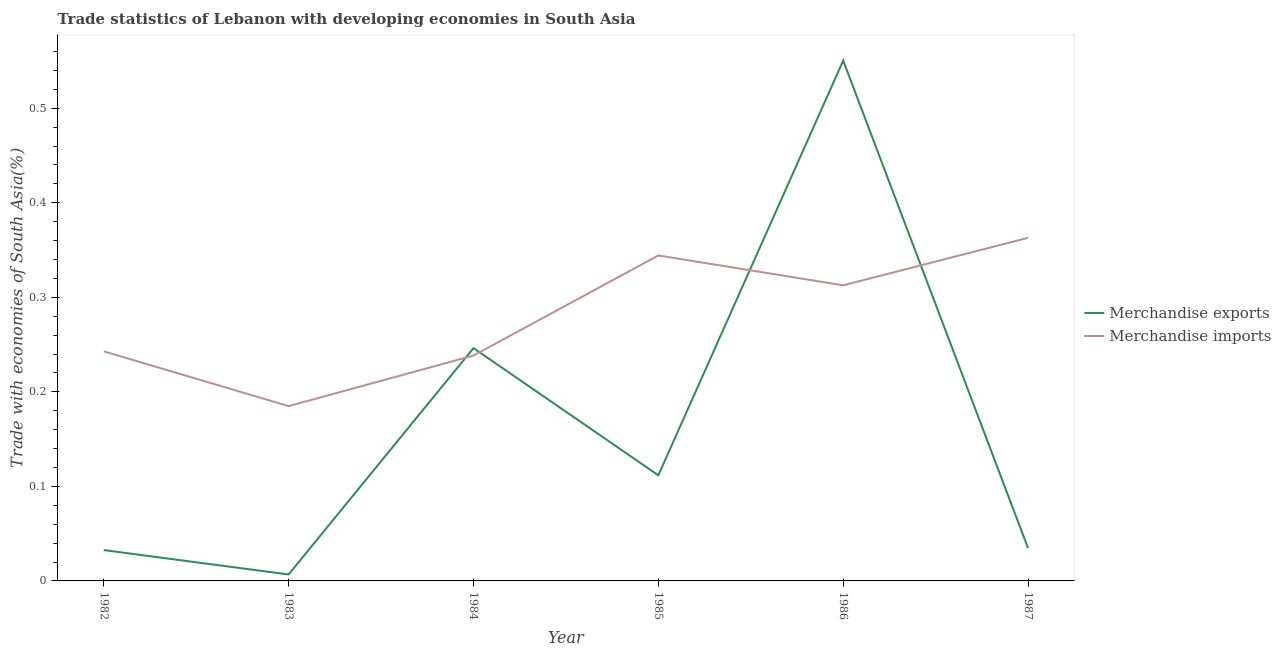Does the line corresponding to merchandise imports intersect with the line corresponding to merchandise exports?
Provide a succinct answer. Yes. What is the merchandise imports in 1987?
Offer a terse response. 0.36. Across all years, what is the maximum merchandise exports?
Your answer should be very brief. 0.55. Across all years, what is the minimum merchandise exports?
Your response must be concise. 0.01. In which year was the merchandise imports maximum?
Your answer should be very brief. 1987. In which year was the merchandise exports minimum?
Offer a terse response. 1983. What is the total merchandise imports in the graph?
Your answer should be compact. 1.69. What is the difference between the merchandise exports in 1983 and that in 1984?
Your answer should be very brief. -0.24. What is the difference between the merchandise imports in 1985 and the merchandise exports in 1983?
Make the answer very short. 0.34. What is the average merchandise imports per year?
Offer a very short reply. 0.28. In the year 1987, what is the difference between the merchandise exports and merchandise imports?
Make the answer very short. -0.33. What is the ratio of the merchandise imports in 1983 to that in 1987?
Keep it short and to the point. 0.51. Is the merchandise exports in 1983 less than that in 1984?
Offer a terse response. Yes. What is the difference between the highest and the second highest merchandise exports?
Make the answer very short. 0.3. What is the difference between the highest and the lowest merchandise exports?
Your response must be concise. 0.54. In how many years, is the merchandise imports greater than the average merchandise imports taken over all years?
Your answer should be compact. 3. Is the merchandise imports strictly greater than the merchandise exports over the years?
Offer a terse response. No. What is the difference between two consecutive major ticks on the Y-axis?
Keep it short and to the point. 0.1. Does the graph contain any zero values?
Provide a succinct answer. No. Does the graph contain grids?
Give a very brief answer. No. How many legend labels are there?
Provide a succinct answer. 2. How are the legend labels stacked?
Your answer should be very brief. Vertical. What is the title of the graph?
Offer a very short reply. Trade statistics of Lebanon with developing economies in South Asia. Does "Registered firms" appear as one of the legend labels in the graph?
Offer a very short reply. No. What is the label or title of the X-axis?
Your response must be concise. Year. What is the label or title of the Y-axis?
Give a very brief answer. Trade with economies of South Asia(%). What is the Trade with economies of South Asia(%) of Merchandise exports in 1982?
Give a very brief answer. 0.03. What is the Trade with economies of South Asia(%) of Merchandise imports in 1982?
Offer a very short reply. 0.24. What is the Trade with economies of South Asia(%) in Merchandise exports in 1983?
Offer a very short reply. 0.01. What is the Trade with economies of South Asia(%) in Merchandise imports in 1983?
Your answer should be very brief. 0.18. What is the Trade with economies of South Asia(%) in Merchandise exports in 1984?
Your answer should be compact. 0.25. What is the Trade with economies of South Asia(%) of Merchandise imports in 1984?
Ensure brevity in your answer.  0.24. What is the Trade with economies of South Asia(%) in Merchandise exports in 1985?
Offer a very short reply. 0.11. What is the Trade with economies of South Asia(%) of Merchandise imports in 1985?
Ensure brevity in your answer.  0.34. What is the Trade with economies of South Asia(%) of Merchandise exports in 1986?
Make the answer very short. 0.55. What is the Trade with economies of South Asia(%) in Merchandise imports in 1986?
Offer a terse response. 0.31. What is the Trade with economies of South Asia(%) of Merchandise exports in 1987?
Keep it short and to the point. 0.03. What is the Trade with economies of South Asia(%) of Merchandise imports in 1987?
Ensure brevity in your answer.  0.36. Across all years, what is the maximum Trade with economies of South Asia(%) in Merchandise exports?
Your response must be concise. 0.55. Across all years, what is the maximum Trade with economies of South Asia(%) of Merchandise imports?
Make the answer very short. 0.36. Across all years, what is the minimum Trade with economies of South Asia(%) in Merchandise exports?
Ensure brevity in your answer.  0.01. Across all years, what is the minimum Trade with economies of South Asia(%) in Merchandise imports?
Offer a very short reply. 0.18. What is the total Trade with economies of South Asia(%) of Merchandise exports in the graph?
Provide a succinct answer. 0.98. What is the total Trade with economies of South Asia(%) in Merchandise imports in the graph?
Provide a succinct answer. 1.69. What is the difference between the Trade with economies of South Asia(%) of Merchandise exports in 1982 and that in 1983?
Make the answer very short. 0.03. What is the difference between the Trade with economies of South Asia(%) of Merchandise imports in 1982 and that in 1983?
Keep it short and to the point. 0.06. What is the difference between the Trade with economies of South Asia(%) in Merchandise exports in 1982 and that in 1984?
Offer a very short reply. -0.21. What is the difference between the Trade with economies of South Asia(%) in Merchandise imports in 1982 and that in 1984?
Keep it short and to the point. 0. What is the difference between the Trade with economies of South Asia(%) in Merchandise exports in 1982 and that in 1985?
Your answer should be compact. -0.08. What is the difference between the Trade with economies of South Asia(%) in Merchandise imports in 1982 and that in 1985?
Provide a succinct answer. -0.1. What is the difference between the Trade with economies of South Asia(%) of Merchandise exports in 1982 and that in 1986?
Give a very brief answer. -0.52. What is the difference between the Trade with economies of South Asia(%) of Merchandise imports in 1982 and that in 1986?
Keep it short and to the point. -0.07. What is the difference between the Trade with economies of South Asia(%) in Merchandise exports in 1982 and that in 1987?
Provide a succinct answer. -0. What is the difference between the Trade with economies of South Asia(%) of Merchandise imports in 1982 and that in 1987?
Give a very brief answer. -0.12. What is the difference between the Trade with economies of South Asia(%) in Merchandise exports in 1983 and that in 1984?
Provide a succinct answer. -0.24. What is the difference between the Trade with economies of South Asia(%) in Merchandise imports in 1983 and that in 1984?
Make the answer very short. -0.05. What is the difference between the Trade with economies of South Asia(%) of Merchandise exports in 1983 and that in 1985?
Offer a very short reply. -0.1. What is the difference between the Trade with economies of South Asia(%) of Merchandise imports in 1983 and that in 1985?
Your answer should be very brief. -0.16. What is the difference between the Trade with economies of South Asia(%) of Merchandise exports in 1983 and that in 1986?
Give a very brief answer. -0.54. What is the difference between the Trade with economies of South Asia(%) of Merchandise imports in 1983 and that in 1986?
Offer a terse response. -0.13. What is the difference between the Trade with economies of South Asia(%) of Merchandise exports in 1983 and that in 1987?
Your response must be concise. -0.03. What is the difference between the Trade with economies of South Asia(%) in Merchandise imports in 1983 and that in 1987?
Keep it short and to the point. -0.18. What is the difference between the Trade with economies of South Asia(%) in Merchandise exports in 1984 and that in 1985?
Keep it short and to the point. 0.13. What is the difference between the Trade with economies of South Asia(%) of Merchandise imports in 1984 and that in 1985?
Offer a very short reply. -0.11. What is the difference between the Trade with economies of South Asia(%) of Merchandise exports in 1984 and that in 1986?
Give a very brief answer. -0.3. What is the difference between the Trade with economies of South Asia(%) in Merchandise imports in 1984 and that in 1986?
Offer a very short reply. -0.07. What is the difference between the Trade with economies of South Asia(%) of Merchandise exports in 1984 and that in 1987?
Your answer should be compact. 0.21. What is the difference between the Trade with economies of South Asia(%) of Merchandise imports in 1984 and that in 1987?
Offer a terse response. -0.12. What is the difference between the Trade with economies of South Asia(%) of Merchandise exports in 1985 and that in 1986?
Offer a very short reply. -0.44. What is the difference between the Trade with economies of South Asia(%) of Merchandise imports in 1985 and that in 1986?
Provide a succinct answer. 0.03. What is the difference between the Trade with economies of South Asia(%) of Merchandise exports in 1985 and that in 1987?
Your answer should be compact. 0.08. What is the difference between the Trade with economies of South Asia(%) of Merchandise imports in 1985 and that in 1987?
Make the answer very short. -0.02. What is the difference between the Trade with economies of South Asia(%) in Merchandise exports in 1986 and that in 1987?
Provide a succinct answer. 0.52. What is the difference between the Trade with economies of South Asia(%) in Merchandise imports in 1986 and that in 1987?
Provide a succinct answer. -0.05. What is the difference between the Trade with economies of South Asia(%) in Merchandise exports in 1982 and the Trade with economies of South Asia(%) in Merchandise imports in 1983?
Provide a short and direct response. -0.15. What is the difference between the Trade with economies of South Asia(%) of Merchandise exports in 1982 and the Trade with economies of South Asia(%) of Merchandise imports in 1984?
Your answer should be compact. -0.21. What is the difference between the Trade with economies of South Asia(%) in Merchandise exports in 1982 and the Trade with economies of South Asia(%) in Merchandise imports in 1985?
Your answer should be compact. -0.31. What is the difference between the Trade with economies of South Asia(%) in Merchandise exports in 1982 and the Trade with economies of South Asia(%) in Merchandise imports in 1986?
Offer a terse response. -0.28. What is the difference between the Trade with economies of South Asia(%) in Merchandise exports in 1982 and the Trade with economies of South Asia(%) in Merchandise imports in 1987?
Your answer should be compact. -0.33. What is the difference between the Trade with economies of South Asia(%) in Merchandise exports in 1983 and the Trade with economies of South Asia(%) in Merchandise imports in 1984?
Offer a very short reply. -0.23. What is the difference between the Trade with economies of South Asia(%) of Merchandise exports in 1983 and the Trade with economies of South Asia(%) of Merchandise imports in 1985?
Keep it short and to the point. -0.34. What is the difference between the Trade with economies of South Asia(%) in Merchandise exports in 1983 and the Trade with economies of South Asia(%) in Merchandise imports in 1986?
Give a very brief answer. -0.31. What is the difference between the Trade with economies of South Asia(%) in Merchandise exports in 1983 and the Trade with economies of South Asia(%) in Merchandise imports in 1987?
Make the answer very short. -0.36. What is the difference between the Trade with economies of South Asia(%) in Merchandise exports in 1984 and the Trade with economies of South Asia(%) in Merchandise imports in 1985?
Make the answer very short. -0.1. What is the difference between the Trade with economies of South Asia(%) of Merchandise exports in 1984 and the Trade with economies of South Asia(%) of Merchandise imports in 1986?
Give a very brief answer. -0.07. What is the difference between the Trade with economies of South Asia(%) of Merchandise exports in 1984 and the Trade with economies of South Asia(%) of Merchandise imports in 1987?
Your response must be concise. -0.12. What is the difference between the Trade with economies of South Asia(%) of Merchandise exports in 1985 and the Trade with economies of South Asia(%) of Merchandise imports in 1986?
Keep it short and to the point. -0.2. What is the difference between the Trade with economies of South Asia(%) in Merchandise exports in 1985 and the Trade with economies of South Asia(%) in Merchandise imports in 1987?
Offer a terse response. -0.25. What is the difference between the Trade with economies of South Asia(%) in Merchandise exports in 1986 and the Trade with economies of South Asia(%) in Merchandise imports in 1987?
Give a very brief answer. 0.19. What is the average Trade with economies of South Asia(%) of Merchandise exports per year?
Ensure brevity in your answer.  0.16. What is the average Trade with economies of South Asia(%) in Merchandise imports per year?
Provide a short and direct response. 0.28. In the year 1982, what is the difference between the Trade with economies of South Asia(%) of Merchandise exports and Trade with economies of South Asia(%) of Merchandise imports?
Your response must be concise. -0.21. In the year 1983, what is the difference between the Trade with economies of South Asia(%) in Merchandise exports and Trade with economies of South Asia(%) in Merchandise imports?
Make the answer very short. -0.18. In the year 1984, what is the difference between the Trade with economies of South Asia(%) of Merchandise exports and Trade with economies of South Asia(%) of Merchandise imports?
Your response must be concise. 0.01. In the year 1985, what is the difference between the Trade with economies of South Asia(%) of Merchandise exports and Trade with economies of South Asia(%) of Merchandise imports?
Offer a terse response. -0.23. In the year 1986, what is the difference between the Trade with economies of South Asia(%) of Merchandise exports and Trade with economies of South Asia(%) of Merchandise imports?
Provide a succinct answer. 0.24. In the year 1987, what is the difference between the Trade with economies of South Asia(%) of Merchandise exports and Trade with economies of South Asia(%) of Merchandise imports?
Give a very brief answer. -0.33. What is the ratio of the Trade with economies of South Asia(%) of Merchandise exports in 1982 to that in 1983?
Provide a succinct answer. 4.77. What is the ratio of the Trade with economies of South Asia(%) of Merchandise imports in 1982 to that in 1983?
Provide a succinct answer. 1.31. What is the ratio of the Trade with economies of South Asia(%) of Merchandise exports in 1982 to that in 1984?
Provide a short and direct response. 0.13. What is the ratio of the Trade with economies of South Asia(%) in Merchandise imports in 1982 to that in 1984?
Keep it short and to the point. 1.02. What is the ratio of the Trade with economies of South Asia(%) of Merchandise exports in 1982 to that in 1985?
Keep it short and to the point. 0.29. What is the ratio of the Trade with economies of South Asia(%) in Merchandise imports in 1982 to that in 1985?
Your answer should be very brief. 0.71. What is the ratio of the Trade with economies of South Asia(%) in Merchandise exports in 1982 to that in 1986?
Offer a very short reply. 0.06. What is the ratio of the Trade with economies of South Asia(%) in Merchandise imports in 1982 to that in 1986?
Offer a very short reply. 0.78. What is the ratio of the Trade with economies of South Asia(%) of Merchandise exports in 1982 to that in 1987?
Give a very brief answer. 0.94. What is the ratio of the Trade with economies of South Asia(%) in Merchandise imports in 1982 to that in 1987?
Offer a terse response. 0.67. What is the ratio of the Trade with economies of South Asia(%) in Merchandise exports in 1983 to that in 1984?
Your answer should be very brief. 0.03. What is the ratio of the Trade with economies of South Asia(%) in Merchandise imports in 1983 to that in 1984?
Offer a terse response. 0.78. What is the ratio of the Trade with economies of South Asia(%) of Merchandise exports in 1983 to that in 1985?
Make the answer very short. 0.06. What is the ratio of the Trade with economies of South Asia(%) of Merchandise imports in 1983 to that in 1985?
Make the answer very short. 0.54. What is the ratio of the Trade with economies of South Asia(%) in Merchandise exports in 1983 to that in 1986?
Offer a very short reply. 0.01. What is the ratio of the Trade with economies of South Asia(%) of Merchandise imports in 1983 to that in 1986?
Keep it short and to the point. 0.59. What is the ratio of the Trade with economies of South Asia(%) of Merchandise exports in 1983 to that in 1987?
Provide a short and direct response. 0.2. What is the ratio of the Trade with economies of South Asia(%) in Merchandise imports in 1983 to that in 1987?
Keep it short and to the point. 0.51. What is the ratio of the Trade with economies of South Asia(%) in Merchandise exports in 1984 to that in 1985?
Make the answer very short. 2.2. What is the ratio of the Trade with economies of South Asia(%) of Merchandise imports in 1984 to that in 1985?
Provide a short and direct response. 0.69. What is the ratio of the Trade with economies of South Asia(%) of Merchandise exports in 1984 to that in 1986?
Make the answer very short. 0.45. What is the ratio of the Trade with economies of South Asia(%) of Merchandise imports in 1984 to that in 1986?
Offer a very short reply. 0.76. What is the ratio of the Trade with economies of South Asia(%) in Merchandise exports in 1984 to that in 1987?
Keep it short and to the point. 7.1. What is the ratio of the Trade with economies of South Asia(%) of Merchandise imports in 1984 to that in 1987?
Your answer should be very brief. 0.66. What is the ratio of the Trade with economies of South Asia(%) in Merchandise exports in 1985 to that in 1986?
Your response must be concise. 0.2. What is the ratio of the Trade with economies of South Asia(%) in Merchandise imports in 1985 to that in 1986?
Provide a succinct answer. 1.1. What is the ratio of the Trade with economies of South Asia(%) in Merchandise exports in 1985 to that in 1987?
Give a very brief answer. 3.22. What is the ratio of the Trade with economies of South Asia(%) in Merchandise imports in 1985 to that in 1987?
Ensure brevity in your answer.  0.95. What is the ratio of the Trade with economies of South Asia(%) of Merchandise exports in 1986 to that in 1987?
Make the answer very short. 15.88. What is the ratio of the Trade with economies of South Asia(%) of Merchandise imports in 1986 to that in 1987?
Your answer should be compact. 0.86. What is the difference between the highest and the second highest Trade with economies of South Asia(%) in Merchandise exports?
Your answer should be very brief. 0.3. What is the difference between the highest and the second highest Trade with economies of South Asia(%) of Merchandise imports?
Your answer should be compact. 0.02. What is the difference between the highest and the lowest Trade with economies of South Asia(%) of Merchandise exports?
Your answer should be very brief. 0.54. What is the difference between the highest and the lowest Trade with economies of South Asia(%) in Merchandise imports?
Provide a succinct answer. 0.18. 